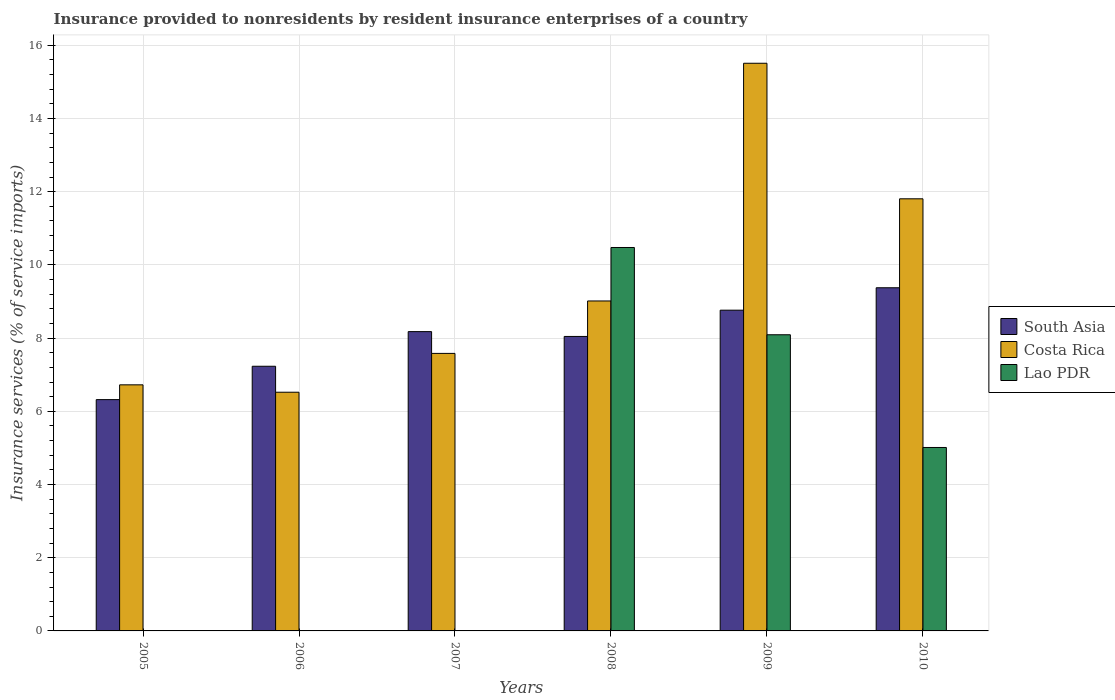Are the number of bars on each tick of the X-axis equal?
Your response must be concise. No. What is the label of the 3rd group of bars from the left?
Provide a short and direct response. 2007. What is the insurance provided to nonresidents in South Asia in 2007?
Offer a very short reply. 8.18. Across all years, what is the maximum insurance provided to nonresidents in Lao PDR?
Keep it short and to the point. 10.48. Across all years, what is the minimum insurance provided to nonresidents in Costa Rica?
Offer a terse response. 6.52. What is the total insurance provided to nonresidents in Lao PDR in the graph?
Offer a terse response. 23.58. What is the difference between the insurance provided to nonresidents in South Asia in 2007 and that in 2009?
Your answer should be compact. -0.59. What is the difference between the insurance provided to nonresidents in Lao PDR in 2010 and the insurance provided to nonresidents in South Asia in 2006?
Your answer should be compact. -2.22. What is the average insurance provided to nonresidents in South Asia per year?
Provide a short and direct response. 7.99. In the year 2010, what is the difference between the insurance provided to nonresidents in Lao PDR and insurance provided to nonresidents in Costa Rica?
Keep it short and to the point. -6.79. In how many years, is the insurance provided to nonresidents in South Asia greater than 15.2 %?
Keep it short and to the point. 0. What is the ratio of the insurance provided to nonresidents in South Asia in 2005 to that in 2007?
Your answer should be very brief. 0.77. What is the difference between the highest and the second highest insurance provided to nonresidents in South Asia?
Ensure brevity in your answer.  0.61. What is the difference between the highest and the lowest insurance provided to nonresidents in Lao PDR?
Make the answer very short. 10.48. In how many years, is the insurance provided to nonresidents in South Asia greater than the average insurance provided to nonresidents in South Asia taken over all years?
Make the answer very short. 4. Is it the case that in every year, the sum of the insurance provided to nonresidents in South Asia and insurance provided to nonresidents in Costa Rica is greater than the insurance provided to nonresidents in Lao PDR?
Offer a very short reply. Yes. How many bars are there?
Your answer should be very brief. 15. How many years are there in the graph?
Give a very brief answer. 6. Are the values on the major ticks of Y-axis written in scientific E-notation?
Make the answer very short. No. Does the graph contain any zero values?
Make the answer very short. Yes. Does the graph contain grids?
Offer a terse response. Yes. Where does the legend appear in the graph?
Provide a succinct answer. Center right. What is the title of the graph?
Ensure brevity in your answer.  Insurance provided to nonresidents by resident insurance enterprises of a country. What is the label or title of the X-axis?
Give a very brief answer. Years. What is the label or title of the Y-axis?
Provide a short and direct response. Insurance services (% of service imports). What is the Insurance services (% of service imports) in South Asia in 2005?
Your answer should be compact. 6.32. What is the Insurance services (% of service imports) in Costa Rica in 2005?
Provide a succinct answer. 6.72. What is the Insurance services (% of service imports) in Lao PDR in 2005?
Offer a terse response. 0. What is the Insurance services (% of service imports) in South Asia in 2006?
Provide a short and direct response. 7.23. What is the Insurance services (% of service imports) of Costa Rica in 2006?
Your response must be concise. 6.52. What is the Insurance services (% of service imports) of Lao PDR in 2006?
Provide a succinct answer. 0. What is the Insurance services (% of service imports) in South Asia in 2007?
Offer a very short reply. 8.18. What is the Insurance services (% of service imports) of Costa Rica in 2007?
Your response must be concise. 7.58. What is the Insurance services (% of service imports) of South Asia in 2008?
Keep it short and to the point. 8.05. What is the Insurance services (% of service imports) of Costa Rica in 2008?
Ensure brevity in your answer.  9.02. What is the Insurance services (% of service imports) in Lao PDR in 2008?
Make the answer very short. 10.48. What is the Insurance services (% of service imports) of South Asia in 2009?
Provide a succinct answer. 8.76. What is the Insurance services (% of service imports) of Costa Rica in 2009?
Make the answer very short. 15.51. What is the Insurance services (% of service imports) in Lao PDR in 2009?
Provide a short and direct response. 8.09. What is the Insurance services (% of service imports) of South Asia in 2010?
Provide a short and direct response. 9.38. What is the Insurance services (% of service imports) of Costa Rica in 2010?
Keep it short and to the point. 11.81. What is the Insurance services (% of service imports) of Lao PDR in 2010?
Make the answer very short. 5.01. Across all years, what is the maximum Insurance services (% of service imports) of South Asia?
Provide a short and direct response. 9.38. Across all years, what is the maximum Insurance services (% of service imports) in Costa Rica?
Keep it short and to the point. 15.51. Across all years, what is the maximum Insurance services (% of service imports) in Lao PDR?
Ensure brevity in your answer.  10.48. Across all years, what is the minimum Insurance services (% of service imports) in South Asia?
Your answer should be compact. 6.32. Across all years, what is the minimum Insurance services (% of service imports) in Costa Rica?
Ensure brevity in your answer.  6.52. Across all years, what is the minimum Insurance services (% of service imports) in Lao PDR?
Keep it short and to the point. 0. What is the total Insurance services (% of service imports) of South Asia in the graph?
Give a very brief answer. 47.91. What is the total Insurance services (% of service imports) of Costa Rica in the graph?
Provide a short and direct response. 57.16. What is the total Insurance services (% of service imports) in Lao PDR in the graph?
Provide a short and direct response. 23.58. What is the difference between the Insurance services (% of service imports) of South Asia in 2005 and that in 2006?
Your answer should be compact. -0.91. What is the difference between the Insurance services (% of service imports) of Costa Rica in 2005 and that in 2006?
Ensure brevity in your answer.  0.2. What is the difference between the Insurance services (% of service imports) in South Asia in 2005 and that in 2007?
Offer a terse response. -1.86. What is the difference between the Insurance services (% of service imports) in Costa Rica in 2005 and that in 2007?
Give a very brief answer. -0.86. What is the difference between the Insurance services (% of service imports) in South Asia in 2005 and that in 2008?
Your answer should be very brief. -1.73. What is the difference between the Insurance services (% of service imports) in Costa Rica in 2005 and that in 2008?
Offer a very short reply. -2.29. What is the difference between the Insurance services (% of service imports) of South Asia in 2005 and that in 2009?
Provide a short and direct response. -2.44. What is the difference between the Insurance services (% of service imports) of Costa Rica in 2005 and that in 2009?
Your response must be concise. -8.79. What is the difference between the Insurance services (% of service imports) in South Asia in 2005 and that in 2010?
Provide a short and direct response. -3.06. What is the difference between the Insurance services (% of service imports) of Costa Rica in 2005 and that in 2010?
Provide a succinct answer. -5.08. What is the difference between the Insurance services (% of service imports) of South Asia in 2006 and that in 2007?
Ensure brevity in your answer.  -0.95. What is the difference between the Insurance services (% of service imports) in Costa Rica in 2006 and that in 2007?
Your response must be concise. -1.06. What is the difference between the Insurance services (% of service imports) of South Asia in 2006 and that in 2008?
Your answer should be very brief. -0.81. What is the difference between the Insurance services (% of service imports) of Costa Rica in 2006 and that in 2008?
Make the answer very short. -2.49. What is the difference between the Insurance services (% of service imports) of South Asia in 2006 and that in 2009?
Keep it short and to the point. -1.53. What is the difference between the Insurance services (% of service imports) of Costa Rica in 2006 and that in 2009?
Provide a short and direct response. -8.99. What is the difference between the Insurance services (% of service imports) of South Asia in 2006 and that in 2010?
Your answer should be compact. -2.14. What is the difference between the Insurance services (% of service imports) of Costa Rica in 2006 and that in 2010?
Offer a terse response. -5.28. What is the difference between the Insurance services (% of service imports) of South Asia in 2007 and that in 2008?
Your answer should be compact. 0.13. What is the difference between the Insurance services (% of service imports) in Costa Rica in 2007 and that in 2008?
Give a very brief answer. -1.43. What is the difference between the Insurance services (% of service imports) in South Asia in 2007 and that in 2009?
Your answer should be very brief. -0.59. What is the difference between the Insurance services (% of service imports) in Costa Rica in 2007 and that in 2009?
Provide a short and direct response. -7.93. What is the difference between the Insurance services (% of service imports) in South Asia in 2007 and that in 2010?
Provide a succinct answer. -1.2. What is the difference between the Insurance services (% of service imports) in Costa Rica in 2007 and that in 2010?
Provide a short and direct response. -4.22. What is the difference between the Insurance services (% of service imports) of South Asia in 2008 and that in 2009?
Your response must be concise. -0.72. What is the difference between the Insurance services (% of service imports) in Costa Rica in 2008 and that in 2009?
Make the answer very short. -6.49. What is the difference between the Insurance services (% of service imports) in Lao PDR in 2008 and that in 2009?
Give a very brief answer. 2.38. What is the difference between the Insurance services (% of service imports) in South Asia in 2008 and that in 2010?
Make the answer very short. -1.33. What is the difference between the Insurance services (% of service imports) of Costa Rica in 2008 and that in 2010?
Offer a very short reply. -2.79. What is the difference between the Insurance services (% of service imports) in Lao PDR in 2008 and that in 2010?
Offer a very short reply. 5.46. What is the difference between the Insurance services (% of service imports) in South Asia in 2009 and that in 2010?
Ensure brevity in your answer.  -0.61. What is the difference between the Insurance services (% of service imports) in Costa Rica in 2009 and that in 2010?
Offer a terse response. 3.7. What is the difference between the Insurance services (% of service imports) in Lao PDR in 2009 and that in 2010?
Offer a very short reply. 3.08. What is the difference between the Insurance services (% of service imports) in South Asia in 2005 and the Insurance services (% of service imports) in Costa Rica in 2006?
Your answer should be compact. -0.2. What is the difference between the Insurance services (% of service imports) in South Asia in 2005 and the Insurance services (% of service imports) in Costa Rica in 2007?
Your answer should be very brief. -1.26. What is the difference between the Insurance services (% of service imports) of South Asia in 2005 and the Insurance services (% of service imports) of Costa Rica in 2008?
Give a very brief answer. -2.7. What is the difference between the Insurance services (% of service imports) of South Asia in 2005 and the Insurance services (% of service imports) of Lao PDR in 2008?
Offer a very short reply. -4.16. What is the difference between the Insurance services (% of service imports) of Costa Rica in 2005 and the Insurance services (% of service imports) of Lao PDR in 2008?
Give a very brief answer. -3.75. What is the difference between the Insurance services (% of service imports) of South Asia in 2005 and the Insurance services (% of service imports) of Costa Rica in 2009?
Your response must be concise. -9.19. What is the difference between the Insurance services (% of service imports) of South Asia in 2005 and the Insurance services (% of service imports) of Lao PDR in 2009?
Provide a succinct answer. -1.77. What is the difference between the Insurance services (% of service imports) in Costa Rica in 2005 and the Insurance services (% of service imports) in Lao PDR in 2009?
Your response must be concise. -1.37. What is the difference between the Insurance services (% of service imports) in South Asia in 2005 and the Insurance services (% of service imports) in Costa Rica in 2010?
Ensure brevity in your answer.  -5.49. What is the difference between the Insurance services (% of service imports) of South Asia in 2005 and the Insurance services (% of service imports) of Lao PDR in 2010?
Your answer should be very brief. 1.31. What is the difference between the Insurance services (% of service imports) of Costa Rica in 2005 and the Insurance services (% of service imports) of Lao PDR in 2010?
Give a very brief answer. 1.71. What is the difference between the Insurance services (% of service imports) of South Asia in 2006 and the Insurance services (% of service imports) of Costa Rica in 2007?
Your response must be concise. -0.35. What is the difference between the Insurance services (% of service imports) of South Asia in 2006 and the Insurance services (% of service imports) of Costa Rica in 2008?
Offer a terse response. -1.78. What is the difference between the Insurance services (% of service imports) in South Asia in 2006 and the Insurance services (% of service imports) in Lao PDR in 2008?
Your answer should be very brief. -3.25. What is the difference between the Insurance services (% of service imports) of Costa Rica in 2006 and the Insurance services (% of service imports) of Lao PDR in 2008?
Provide a short and direct response. -3.95. What is the difference between the Insurance services (% of service imports) of South Asia in 2006 and the Insurance services (% of service imports) of Costa Rica in 2009?
Provide a succinct answer. -8.28. What is the difference between the Insurance services (% of service imports) in South Asia in 2006 and the Insurance services (% of service imports) in Lao PDR in 2009?
Offer a terse response. -0.86. What is the difference between the Insurance services (% of service imports) of Costa Rica in 2006 and the Insurance services (% of service imports) of Lao PDR in 2009?
Provide a succinct answer. -1.57. What is the difference between the Insurance services (% of service imports) in South Asia in 2006 and the Insurance services (% of service imports) in Costa Rica in 2010?
Offer a very short reply. -4.58. What is the difference between the Insurance services (% of service imports) of South Asia in 2006 and the Insurance services (% of service imports) of Lao PDR in 2010?
Ensure brevity in your answer.  2.22. What is the difference between the Insurance services (% of service imports) of Costa Rica in 2006 and the Insurance services (% of service imports) of Lao PDR in 2010?
Your answer should be very brief. 1.51. What is the difference between the Insurance services (% of service imports) in South Asia in 2007 and the Insurance services (% of service imports) in Costa Rica in 2008?
Offer a terse response. -0.84. What is the difference between the Insurance services (% of service imports) of South Asia in 2007 and the Insurance services (% of service imports) of Lao PDR in 2008?
Provide a succinct answer. -2.3. What is the difference between the Insurance services (% of service imports) of Costa Rica in 2007 and the Insurance services (% of service imports) of Lao PDR in 2008?
Make the answer very short. -2.89. What is the difference between the Insurance services (% of service imports) of South Asia in 2007 and the Insurance services (% of service imports) of Costa Rica in 2009?
Your answer should be very brief. -7.33. What is the difference between the Insurance services (% of service imports) of South Asia in 2007 and the Insurance services (% of service imports) of Lao PDR in 2009?
Your answer should be very brief. 0.09. What is the difference between the Insurance services (% of service imports) of Costa Rica in 2007 and the Insurance services (% of service imports) of Lao PDR in 2009?
Your response must be concise. -0.51. What is the difference between the Insurance services (% of service imports) in South Asia in 2007 and the Insurance services (% of service imports) in Costa Rica in 2010?
Provide a succinct answer. -3.63. What is the difference between the Insurance services (% of service imports) of South Asia in 2007 and the Insurance services (% of service imports) of Lao PDR in 2010?
Offer a terse response. 3.17. What is the difference between the Insurance services (% of service imports) of Costa Rica in 2007 and the Insurance services (% of service imports) of Lao PDR in 2010?
Your answer should be compact. 2.57. What is the difference between the Insurance services (% of service imports) of South Asia in 2008 and the Insurance services (% of service imports) of Costa Rica in 2009?
Keep it short and to the point. -7.46. What is the difference between the Insurance services (% of service imports) of South Asia in 2008 and the Insurance services (% of service imports) of Lao PDR in 2009?
Your answer should be very brief. -0.05. What is the difference between the Insurance services (% of service imports) of Costa Rica in 2008 and the Insurance services (% of service imports) of Lao PDR in 2009?
Give a very brief answer. 0.92. What is the difference between the Insurance services (% of service imports) of South Asia in 2008 and the Insurance services (% of service imports) of Costa Rica in 2010?
Make the answer very short. -3.76. What is the difference between the Insurance services (% of service imports) of South Asia in 2008 and the Insurance services (% of service imports) of Lao PDR in 2010?
Your answer should be compact. 3.03. What is the difference between the Insurance services (% of service imports) of Costa Rica in 2008 and the Insurance services (% of service imports) of Lao PDR in 2010?
Give a very brief answer. 4. What is the difference between the Insurance services (% of service imports) of South Asia in 2009 and the Insurance services (% of service imports) of Costa Rica in 2010?
Provide a succinct answer. -3.04. What is the difference between the Insurance services (% of service imports) in South Asia in 2009 and the Insurance services (% of service imports) in Lao PDR in 2010?
Your response must be concise. 3.75. What is the difference between the Insurance services (% of service imports) in Costa Rica in 2009 and the Insurance services (% of service imports) in Lao PDR in 2010?
Provide a short and direct response. 10.5. What is the average Insurance services (% of service imports) in South Asia per year?
Provide a short and direct response. 7.99. What is the average Insurance services (% of service imports) in Costa Rica per year?
Offer a very short reply. 9.53. What is the average Insurance services (% of service imports) of Lao PDR per year?
Keep it short and to the point. 3.93. In the year 2005, what is the difference between the Insurance services (% of service imports) of South Asia and Insurance services (% of service imports) of Costa Rica?
Offer a terse response. -0.4. In the year 2006, what is the difference between the Insurance services (% of service imports) in South Asia and Insurance services (% of service imports) in Costa Rica?
Offer a very short reply. 0.71. In the year 2007, what is the difference between the Insurance services (% of service imports) of South Asia and Insurance services (% of service imports) of Costa Rica?
Your answer should be compact. 0.59. In the year 2008, what is the difference between the Insurance services (% of service imports) of South Asia and Insurance services (% of service imports) of Costa Rica?
Keep it short and to the point. -0.97. In the year 2008, what is the difference between the Insurance services (% of service imports) in South Asia and Insurance services (% of service imports) in Lao PDR?
Your answer should be compact. -2.43. In the year 2008, what is the difference between the Insurance services (% of service imports) of Costa Rica and Insurance services (% of service imports) of Lao PDR?
Offer a very short reply. -1.46. In the year 2009, what is the difference between the Insurance services (% of service imports) of South Asia and Insurance services (% of service imports) of Costa Rica?
Make the answer very short. -6.75. In the year 2009, what is the difference between the Insurance services (% of service imports) of South Asia and Insurance services (% of service imports) of Lao PDR?
Your response must be concise. 0.67. In the year 2009, what is the difference between the Insurance services (% of service imports) of Costa Rica and Insurance services (% of service imports) of Lao PDR?
Make the answer very short. 7.42. In the year 2010, what is the difference between the Insurance services (% of service imports) in South Asia and Insurance services (% of service imports) in Costa Rica?
Ensure brevity in your answer.  -2.43. In the year 2010, what is the difference between the Insurance services (% of service imports) in South Asia and Insurance services (% of service imports) in Lao PDR?
Your answer should be very brief. 4.36. In the year 2010, what is the difference between the Insurance services (% of service imports) in Costa Rica and Insurance services (% of service imports) in Lao PDR?
Your answer should be compact. 6.79. What is the ratio of the Insurance services (% of service imports) in South Asia in 2005 to that in 2006?
Your answer should be very brief. 0.87. What is the ratio of the Insurance services (% of service imports) of Costa Rica in 2005 to that in 2006?
Keep it short and to the point. 1.03. What is the ratio of the Insurance services (% of service imports) in South Asia in 2005 to that in 2007?
Give a very brief answer. 0.77. What is the ratio of the Insurance services (% of service imports) of Costa Rica in 2005 to that in 2007?
Give a very brief answer. 0.89. What is the ratio of the Insurance services (% of service imports) in South Asia in 2005 to that in 2008?
Give a very brief answer. 0.79. What is the ratio of the Insurance services (% of service imports) of Costa Rica in 2005 to that in 2008?
Make the answer very short. 0.75. What is the ratio of the Insurance services (% of service imports) of South Asia in 2005 to that in 2009?
Give a very brief answer. 0.72. What is the ratio of the Insurance services (% of service imports) of Costa Rica in 2005 to that in 2009?
Make the answer very short. 0.43. What is the ratio of the Insurance services (% of service imports) of South Asia in 2005 to that in 2010?
Ensure brevity in your answer.  0.67. What is the ratio of the Insurance services (% of service imports) of Costa Rica in 2005 to that in 2010?
Offer a terse response. 0.57. What is the ratio of the Insurance services (% of service imports) of South Asia in 2006 to that in 2007?
Offer a terse response. 0.88. What is the ratio of the Insurance services (% of service imports) in Costa Rica in 2006 to that in 2007?
Offer a very short reply. 0.86. What is the ratio of the Insurance services (% of service imports) in South Asia in 2006 to that in 2008?
Ensure brevity in your answer.  0.9. What is the ratio of the Insurance services (% of service imports) of Costa Rica in 2006 to that in 2008?
Provide a short and direct response. 0.72. What is the ratio of the Insurance services (% of service imports) in South Asia in 2006 to that in 2009?
Provide a short and direct response. 0.83. What is the ratio of the Insurance services (% of service imports) in Costa Rica in 2006 to that in 2009?
Your answer should be compact. 0.42. What is the ratio of the Insurance services (% of service imports) of South Asia in 2006 to that in 2010?
Provide a succinct answer. 0.77. What is the ratio of the Insurance services (% of service imports) of Costa Rica in 2006 to that in 2010?
Ensure brevity in your answer.  0.55. What is the ratio of the Insurance services (% of service imports) in South Asia in 2007 to that in 2008?
Ensure brevity in your answer.  1.02. What is the ratio of the Insurance services (% of service imports) in Costa Rica in 2007 to that in 2008?
Make the answer very short. 0.84. What is the ratio of the Insurance services (% of service imports) of South Asia in 2007 to that in 2009?
Your answer should be compact. 0.93. What is the ratio of the Insurance services (% of service imports) of Costa Rica in 2007 to that in 2009?
Provide a succinct answer. 0.49. What is the ratio of the Insurance services (% of service imports) of South Asia in 2007 to that in 2010?
Your answer should be compact. 0.87. What is the ratio of the Insurance services (% of service imports) of Costa Rica in 2007 to that in 2010?
Give a very brief answer. 0.64. What is the ratio of the Insurance services (% of service imports) of South Asia in 2008 to that in 2009?
Your answer should be very brief. 0.92. What is the ratio of the Insurance services (% of service imports) in Costa Rica in 2008 to that in 2009?
Your answer should be compact. 0.58. What is the ratio of the Insurance services (% of service imports) of Lao PDR in 2008 to that in 2009?
Your answer should be very brief. 1.29. What is the ratio of the Insurance services (% of service imports) in South Asia in 2008 to that in 2010?
Make the answer very short. 0.86. What is the ratio of the Insurance services (% of service imports) in Costa Rica in 2008 to that in 2010?
Your answer should be compact. 0.76. What is the ratio of the Insurance services (% of service imports) in Lao PDR in 2008 to that in 2010?
Your response must be concise. 2.09. What is the ratio of the Insurance services (% of service imports) in South Asia in 2009 to that in 2010?
Keep it short and to the point. 0.93. What is the ratio of the Insurance services (% of service imports) in Costa Rica in 2009 to that in 2010?
Keep it short and to the point. 1.31. What is the ratio of the Insurance services (% of service imports) of Lao PDR in 2009 to that in 2010?
Offer a very short reply. 1.61. What is the difference between the highest and the second highest Insurance services (% of service imports) in South Asia?
Keep it short and to the point. 0.61. What is the difference between the highest and the second highest Insurance services (% of service imports) of Costa Rica?
Give a very brief answer. 3.7. What is the difference between the highest and the second highest Insurance services (% of service imports) in Lao PDR?
Offer a terse response. 2.38. What is the difference between the highest and the lowest Insurance services (% of service imports) of South Asia?
Ensure brevity in your answer.  3.06. What is the difference between the highest and the lowest Insurance services (% of service imports) of Costa Rica?
Your answer should be compact. 8.99. What is the difference between the highest and the lowest Insurance services (% of service imports) in Lao PDR?
Keep it short and to the point. 10.48. 